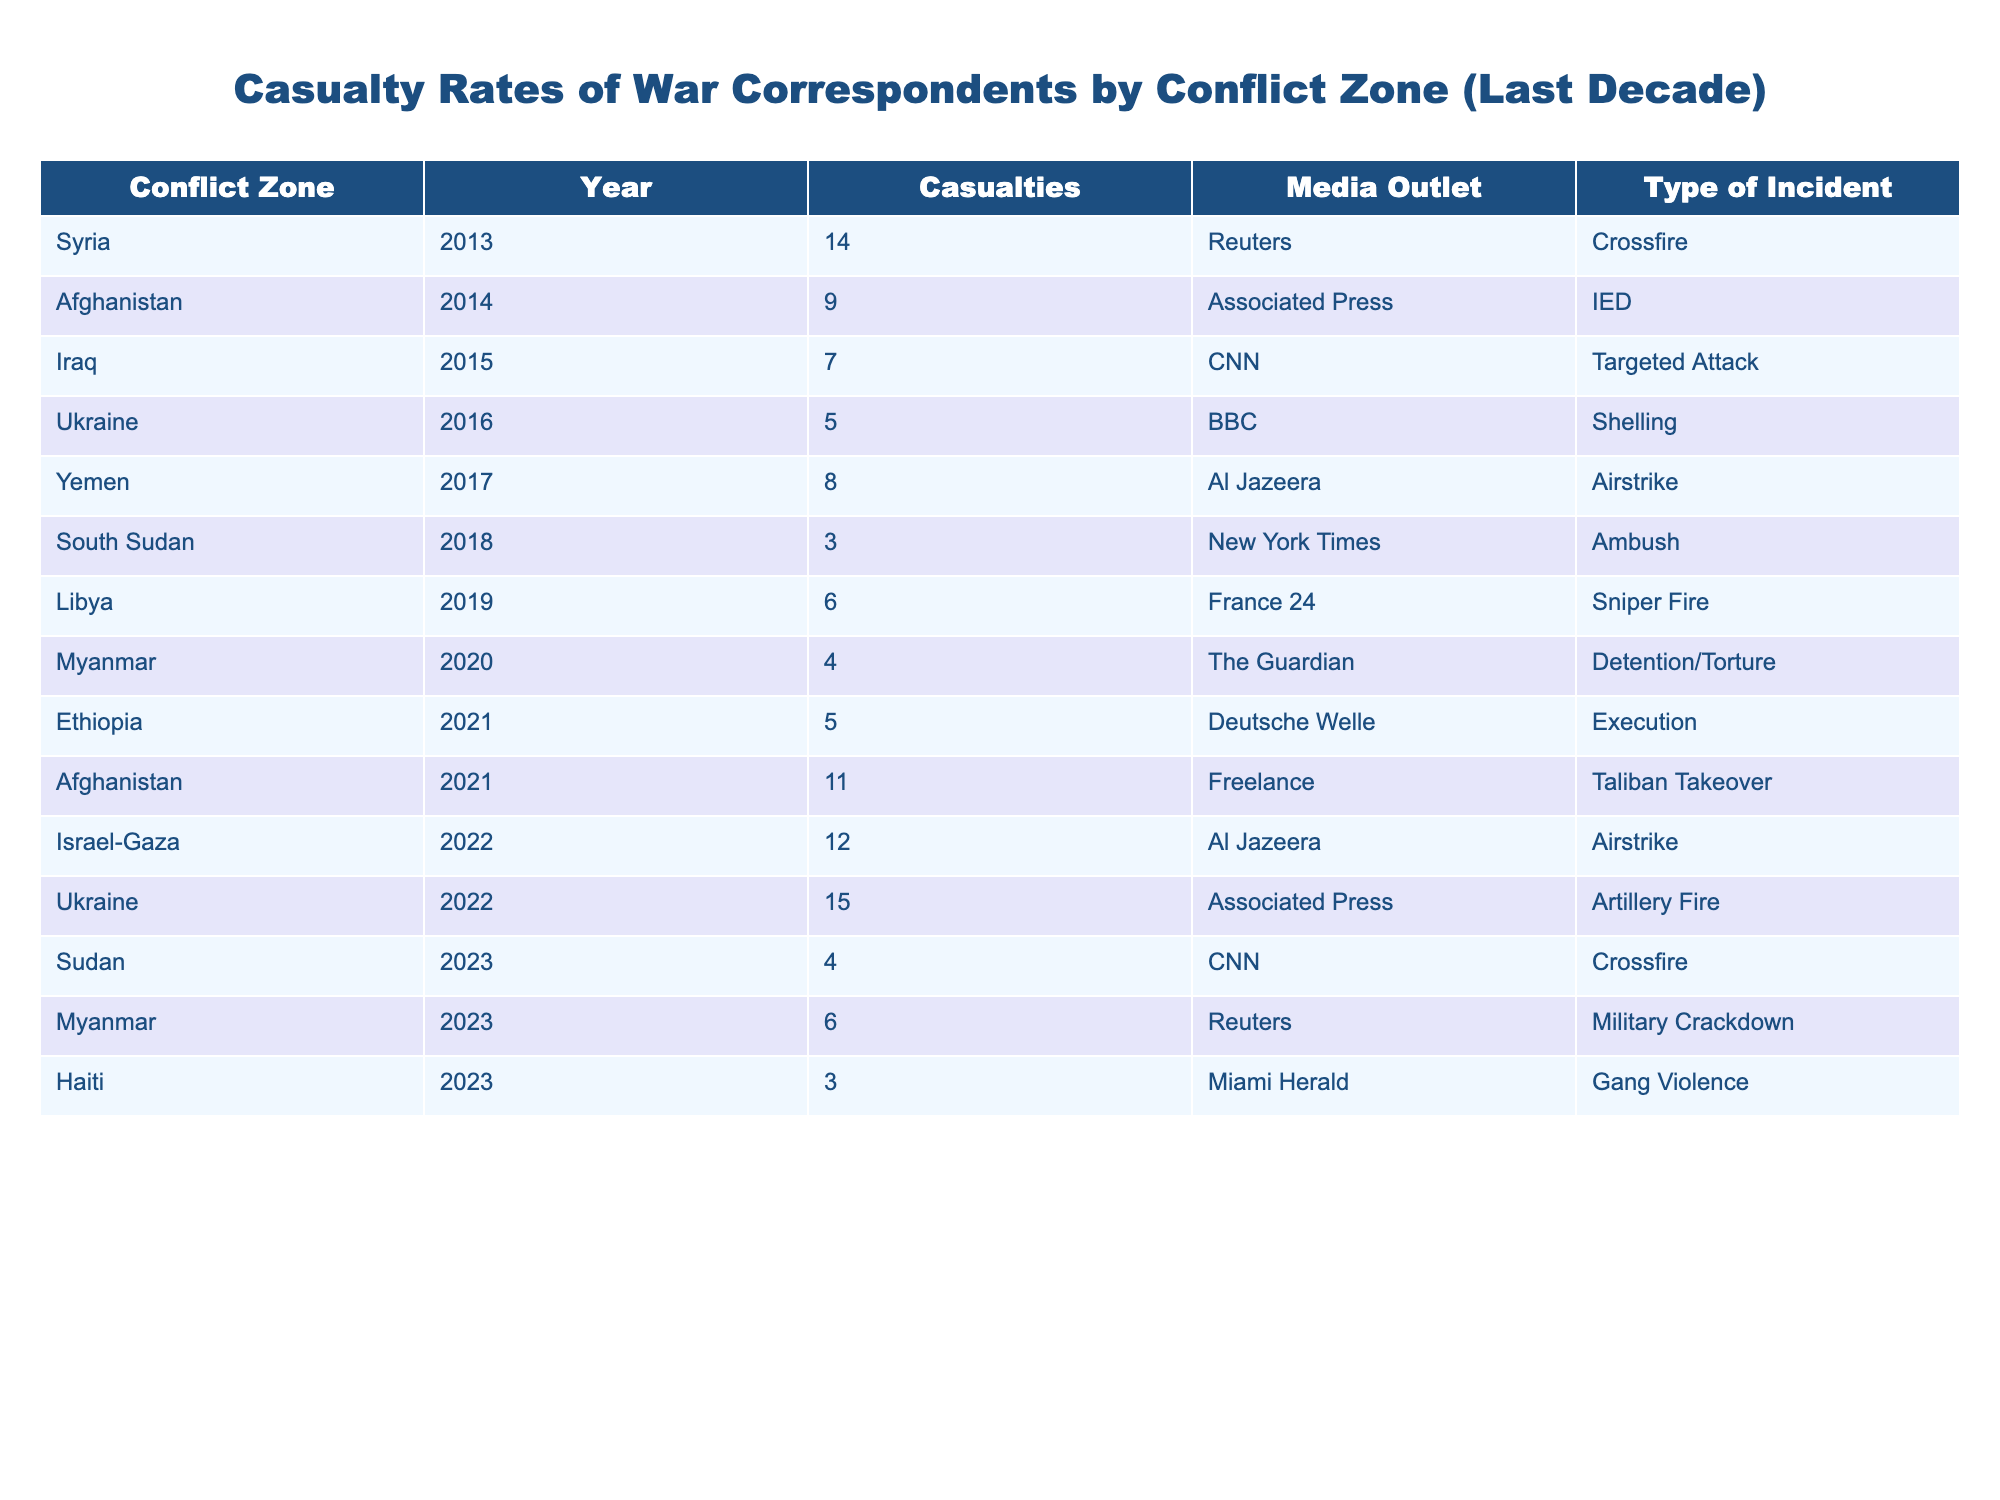What was the highest number of casualties for war correspondents in a single year? Looking at the table, the highest number of casualties listed is 15 in the year 2022 for Ukraine.
Answer: 15 Which conflict zone had the least casualties in the data provided? The conflict zone with the least casualties is South Sudan in 2018, with only 3 casualties.
Answer: South Sudan How many casualties were recorded in Afghanistan across the years presented? The injuries in Afghanistan were 9 in 2014 and 11 in 2021. Summing these gives 9 + 11 = 20 casualties in total.
Answer: 20 Was there a year where casualties increased compared to the previous year in the same conflict zone? Yes, in Afghanistan, the casualties increased from 9 in 2014 to 11 in 2021, which is an increase of 2.
Answer: Yes What was the average number of casualties for war correspondents in 2023? The casualties recorded in 2023 were 4 in Sudan, 6 in Myanmar, and 3 in Haiti. The average is (4 + 6 + 3)/3 = 13/3 = 4.33, rounding down gives approximately 4.
Answer: 4 In which conflict zone and year did the event labeled "Airstrike" lead to the highest casualties? Looking at the table, the conflict zone with "Airstrike" that had the highest number of casualties is Ukraine in 2022, with 15 casualties.
Answer: Ukraine, 2022 How many more casualties were reported in Syria compared to Libya? Syria had 14 casualties in 2013, while Libya had 6 in 2019. The difference is 14 - 6 = 8 casualties more in Syria.
Answer: 8 Was there any incident categorized under "Military Crackdown"? If so, which year and conflict zone does it correspond to? Yes, there was an incident categorized under "Military Crackdown" in Myanmar in the year 2023.
Answer: Yes, Myanmar, 2023 What is the total number of casualties recorded in the conflict zones of Yemen and Iraq combined? Yemen had 8 casualties in 2017, and Iraq had 7 in 2015. Adding these gives 8 + 7 = 15 total casualties combined.
Answer: 15 Which media outlet reported on the most conflict zones as per the data? By reviewing the table, Al Jazeera reported in Yemen and Israel-Gaza, contributing to 2 conflict zones. However, other outlets like CNN and Reuters also reported on more than one zone leading to a tie.
Answer: Tie among multiple outlets 